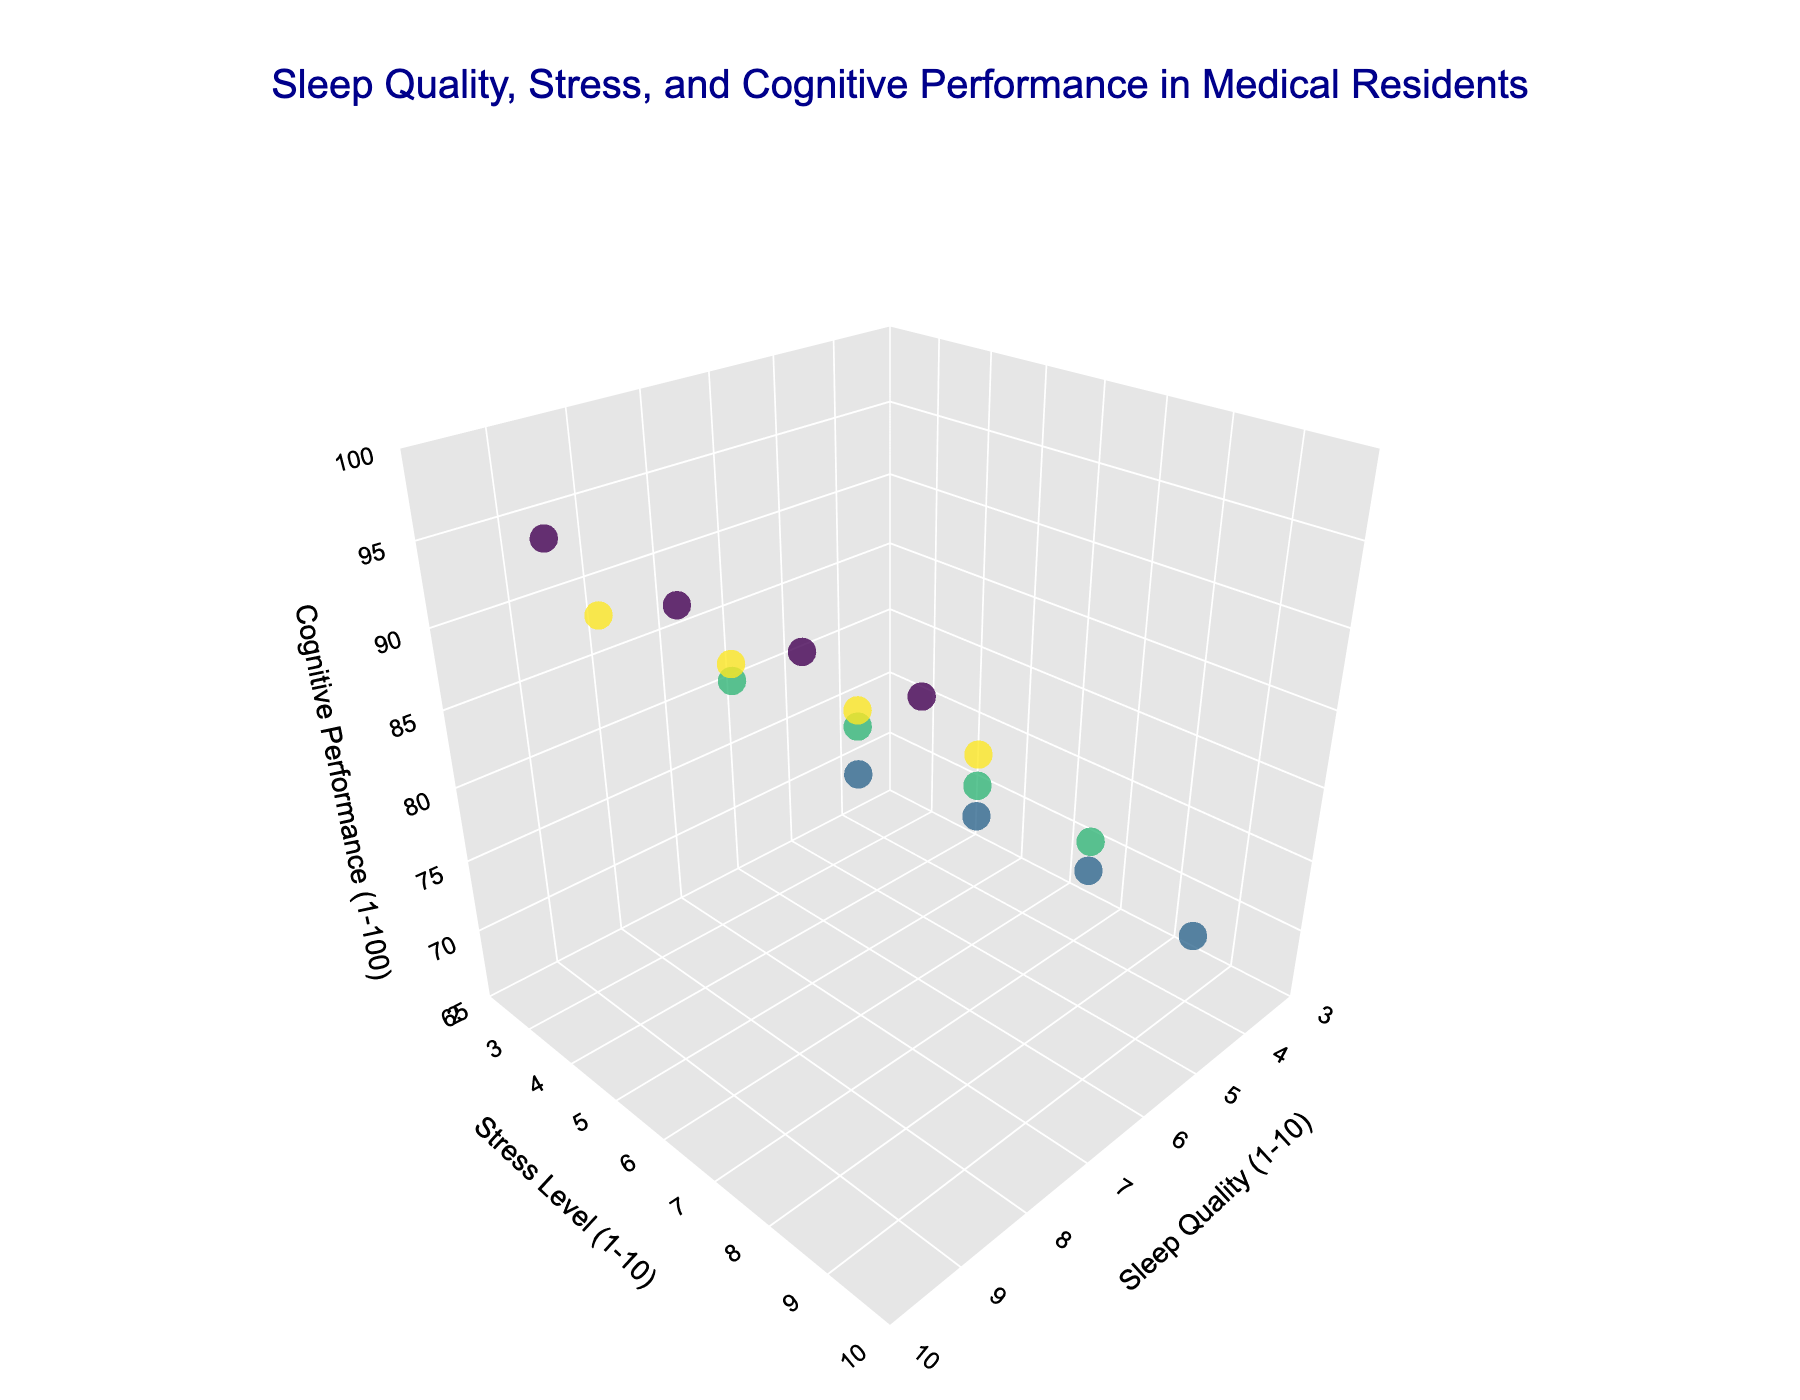What is the title of the plot? The title is written in a larger and distinct font at the top of the plot.
Answer: Sleep Quality, Stress, and Cognitive Performance in Medical Residents What are the axis labels on the plot? The axis labels are located next to each axis. The x-axis is labeled "Sleep Quality (1-10)", the y-axis is labeled "Stress Level (1-10)", and the z-axis is labeled "Cognitive Performance (1-100)".
Answer: Sleep Quality (1-10), Stress Level (1-10), Cognitive Performance (1-100) How many data points are represented in the plot? Counting the markers/points present in the 3D scatter plot will give the number of data points.
Answer: 16 Which training stage appears to have the highest average sleep quality? By visually inspecting the plot, observe where most of the markers for each training stage are positioned on the sleep quality axis.
Answer: Fellow Which training stage has the highest cognitive performance? By looking at the z-axis and the position of the markers for each training stage, identify which stage has the highest values.
Answer: Fellow Is there a visible trend between stress level and cognitive performance? Inspect the relationship between the y-axis (stress level) and the z-axis (cognitive performance) by observing the markers. Generally, higher stress levels seem to correspond with lower cognitive performance.
Answer: Higher stress levels generally correspond with lower cognitive performance What is the range of sleep quality ratings for second-year residents? Check the x-axis positions of the markers corresponding to "Second Year Resident" to find the minimum and maximum values.
Answer: 5 to 8 Do residents at different training stages cluster in distinct regions of the plot? Look at the distribution of markers colored by training stage to see if there are distinct clusters.
Answer: Yes, they cluster based on sleep quality and stress levels Which marker represents a first-year resident with the highest cognitive performance? Locate the markers labeled as "First Year Resident" and identify the one with the highest z-axis value.
Answer: The marker at (7, 6, 82) On average, how does sleep quality change from first year to fellow? By observing the x-axis positions for different stages, calculate the average sleep quality for both groups and compare.
Answer: Increases on average from 5.5 to 7.5 